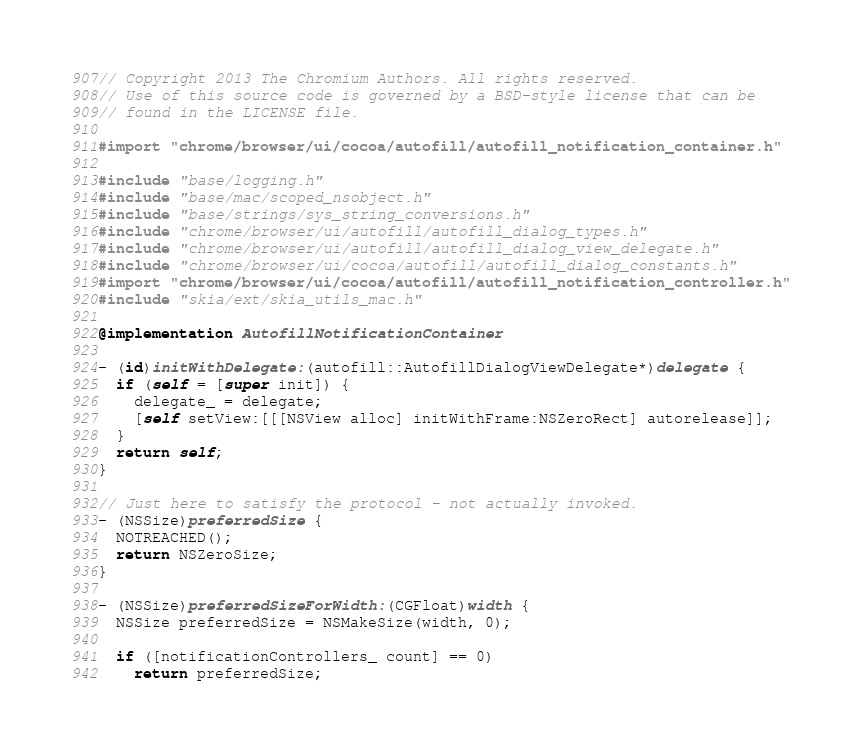Convert code to text. <code><loc_0><loc_0><loc_500><loc_500><_ObjectiveC_>// Copyright 2013 The Chromium Authors. All rights reserved.
// Use of this source code is governed by a BSD-style license that can be
// found in the LICENSE file.

#import "chrome/browser/ui/cocoa/autofill/autofill_notification_container.h"

#include "base/logging.h"
#include "base/mac/scoped_nsobject.h"
#include "base/strings/sys_string_conversions.h"
#include "chrome/browser/ui/autofill/autofill_dialog_types.h"
#include "chrome/browser/ui/autofill/autofill_dialog_view_delegate.h"
#include "chrome/browser/ui/cocoa/autofill/autofill_dialog_constants.h"
#import "chrome/browser/ui/cocoa/autofill/autofill_notification_controller.h"
#include "skia/ext/skia_utils_mac.h"

@implementation AutofillNotificationContainer

- (id)initWithDelegate:(autofill::AutofillDialogViewDelegate*)delegate {
  if (self = [super init]) {
    delegate_ = delegate;
    [self setView:[[[NSView alloc] initWithFrame:NSZeroRect] autorelease]];
  }
  return self;
}

// Just here to satisfy the protocol - not actually invoked.
- (NSSize)preferredSize {
  NOTREACHED();
  return NSZeroSize;
}

- (NSSize)preferredSizeForWidth:(CGFloat)width {
  NSSize preferredSize = NSMakeSize(width, 0);

  if ([notificationControllers_ count] == 0)
    return preferredSize;
</code> 